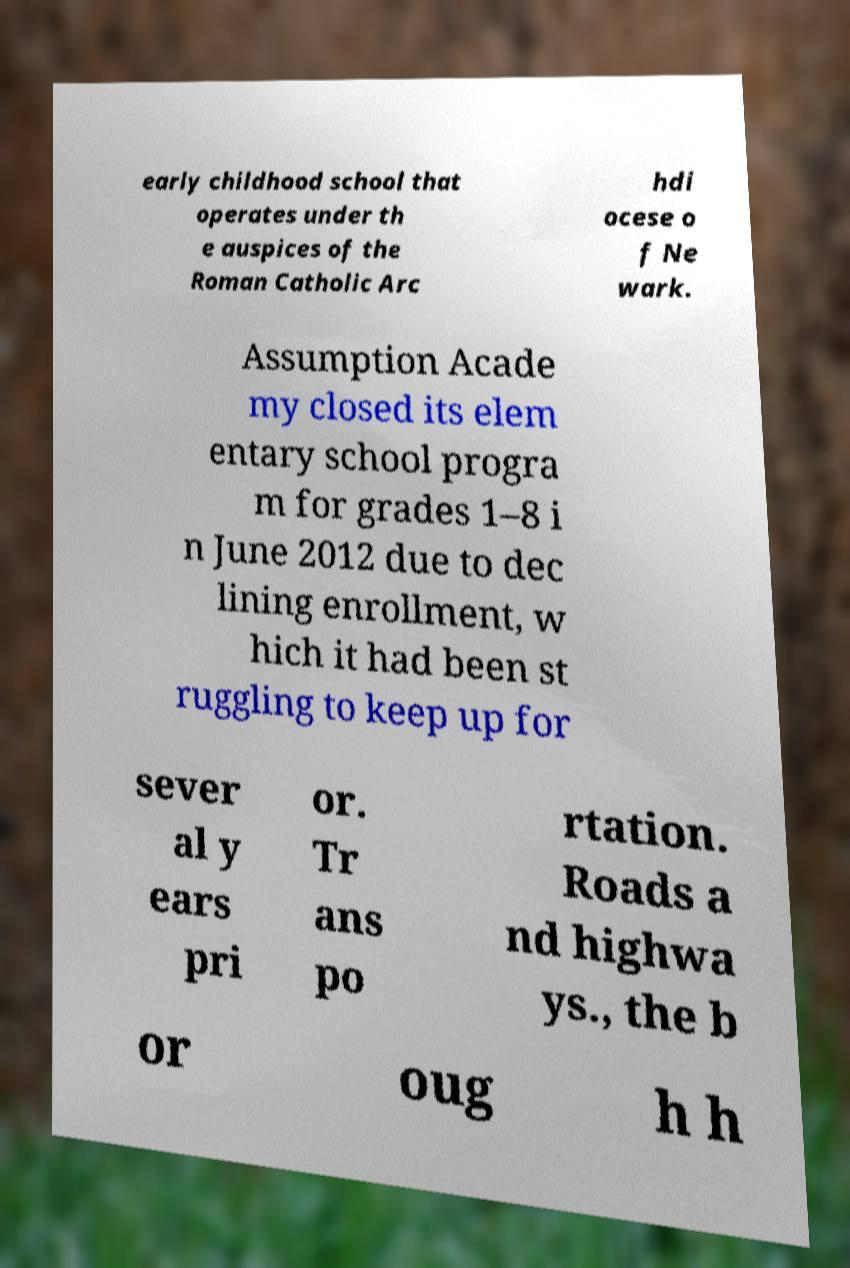Could you extract and type out the text from this image? early childhood school that operates under th e auspices of the Roman Catholic Arc hdi ocese o f Ne wark. Assumption Acade my closed its elem entary school progra m for grades 1–8 i n June 2012 due to dec lining enrollment, w hich it had been st ruggling to keep up for sever al y ears pri or. Tr ans po rtation. Roads a nd highwa ys., the b or oug h h 